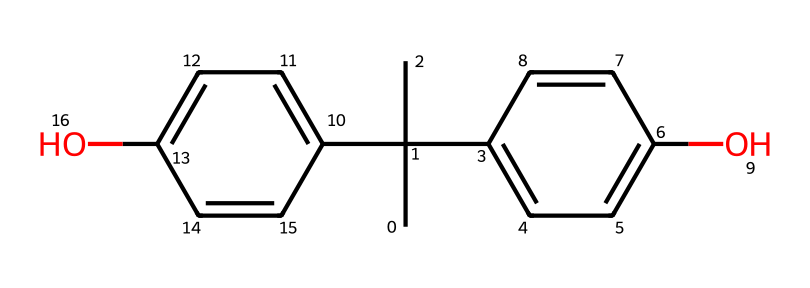What is the chemical name represented by this SMILES structure? The SMILES notation corresponds to a chemical structure that includes two hydroxyphenyl groups attached to a branched carbon chain, which identifies it as bisphenol A.
Answer: bisphenol A How many carbon atoms are in the structure? By analyzing the SMILES representation, we can count the carbon atoms represented in the structure. The notation indicates there are fifteen carbon atoms in total.
Answer: fifteen What type of functional groups are present in the chemical structure? The structure contains two hydroxyl (-OH) groups that are characteristic of phenolic compounds, indicating the presence of phenolic functional groups.
Answer: hydroxyl groups Is this chemical commonly found in office supplies? Bisphenol A (BPA) is widely used in the production of polycarbonate plastics and epoxy resins, which are common materials in various office supplies such as plastic containers and coatings, confirming its presence in these products.
Answer: yes What is the significance of the hydroxyl groups in terms of toxicity? The hydroxyl groups in bisphenol A contribute to its ability to mimic estrogen, which is linked to various health risks, making the compound considered toxic due to endocrine-disrupting properties.
Answer: endocrine disruptors How many double bonds are present in the structure? Analyzing the SMILES reveals the presence of four double bonds between carbon atoms in the phenolic rings and the branched carbon chains.
Answer: four What type of chemical is bisphenol A classified as? Bisphenol A is classified as an organic compound and specifically categorized under phenolic compounds due to its structural features including hydroxyl groups attached to aromatic rings.
Answer: phenolic compound 